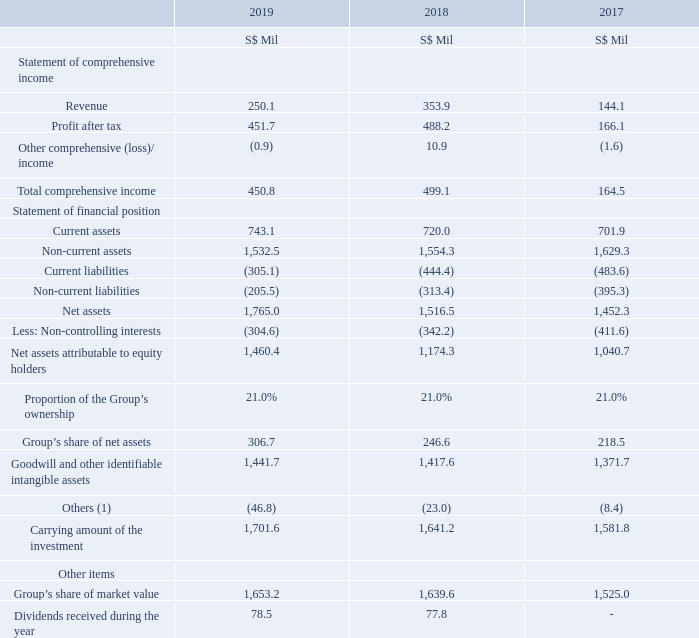23. Associates (Cont'd)
The summarised financial information of the Group’s significant associate namely Intouch Holdings Public Company Limited (“Intouch”), based on its financial statements and a reconciliation with the carrying amount of the investment in the consolidated financial statements was as follows –
Note: (1) Others include adjustments to align the respective local accounting standards to SFRS(I).
Which associate's information does this note contain? Intouch holdings public company limited. What information does the line item 'Others' relate to? Adjustments to align the respective local accounting standards to sfrs(i). What other information is provided other than financial information from the statement of comprehensive income and statement of financial position? Group’s share of market value, dividends received during the year. What is the % change in carrying amount from 2017 to 2019?
Answer scale should be: percent.  (1,701.6 - 1,581.8) / 1,581.8 * 100
Answer: 7.57. In which year was the total comprehensive income the highest? 499.1 > 450.8 > 164.5
Answer: 2018. How many different categories of items are there in the statement of financial position? Current assets##Non-current assets##Current Liabilities##Non-current liabilities 
Answer: 4. 